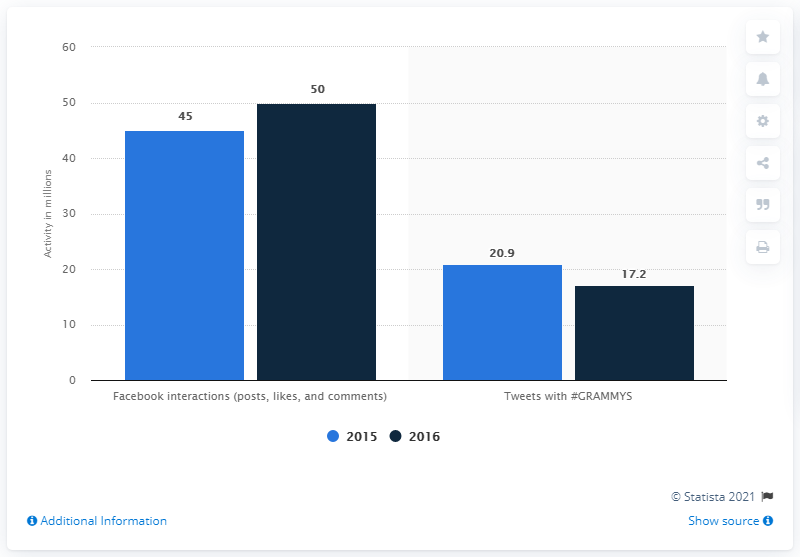Mention a couple of crucial points in this snapshot. In 2016, there were approximately 50 Facebook interactions. 